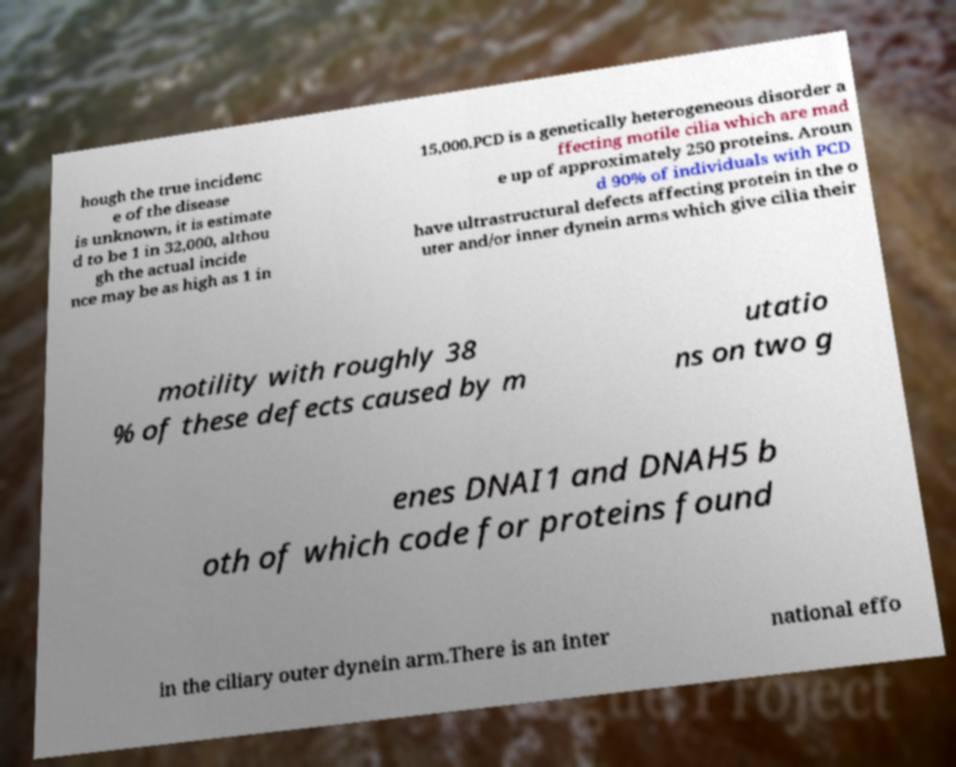Please identify and transcribe the text found in this image. hough the true incidenc e of the disease is unknown, it is estimate d to be 1 in 32,000, althou gh the actual incide nce may be as high as 1 in 15,000.PCD is a genetically heterogeneous disorder a ffecting motile cilia which are mad e up of approximately 250 proteins. Aroun d 90% of individuals with PCD have ultrastructural defects affecting protein in the o uter and/or inner dynein arms which give cilia their motility with roughly 38 % of these defects caused by m utatio ns on two g enes DNAI1 and DNAH5 b oth of which code for proteins found in the ciliary outer dynein arm.There is an inter national effo 